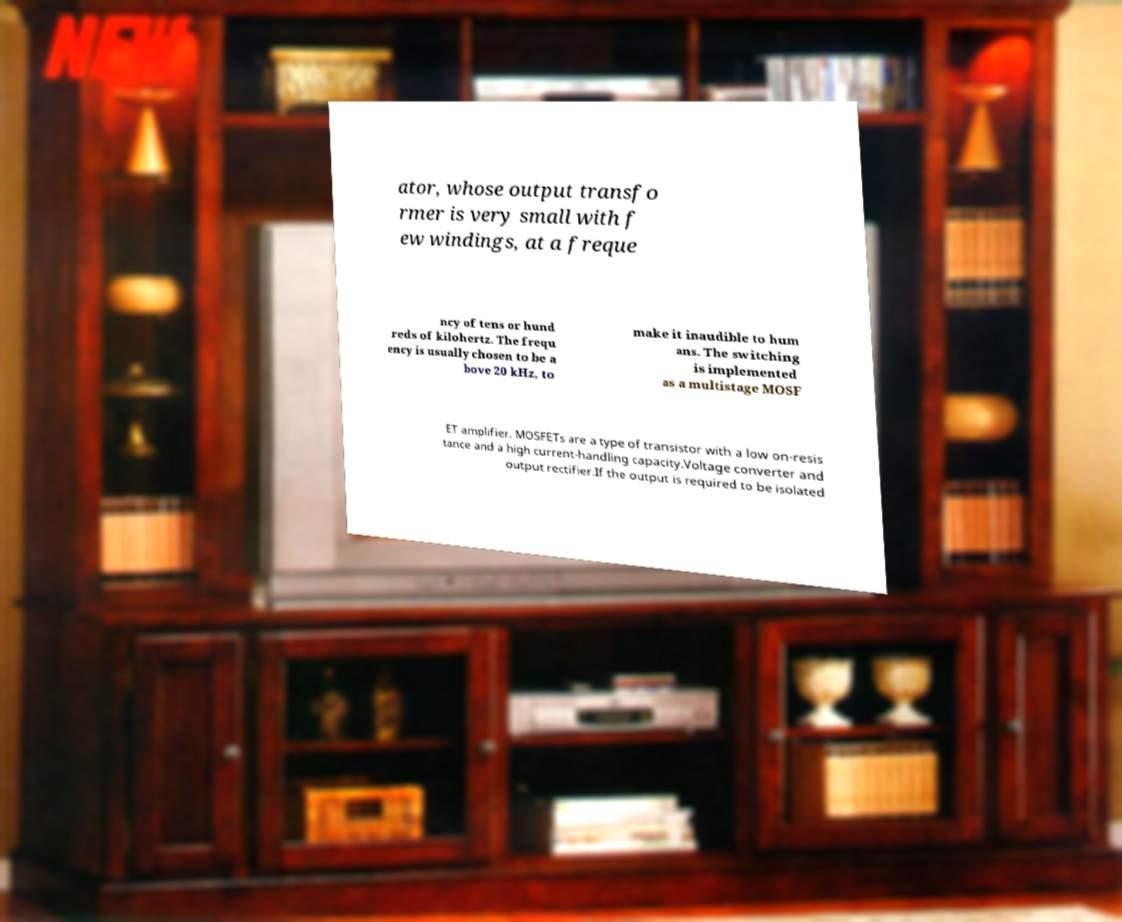For documentation purposes, I need the text within this image transcribed. Could you provide that? ator, whose output transfo rmer is very small with f ew windings, at a freque ncy of tens or hund reds of kilohertz. The frequ ency is usually chosen to be a bove 20 kHz, to make it inaudible to hum ans. The switching is implemented as a multistage MOSF ET amplifier. MOSFETs are a type of transistor with a low on-resis tance and a high current-handling capacity.Voltage converter and output rectifier.If the output is required to be isolated 